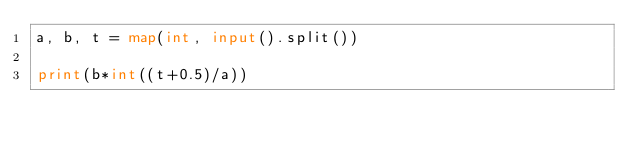Convert code to text. <code><loc_0><loc_0><loc_500><loc_500><_Python_>a, b, t = map(int, input().split())

print(b*int((t+0.5)/a))</code> 